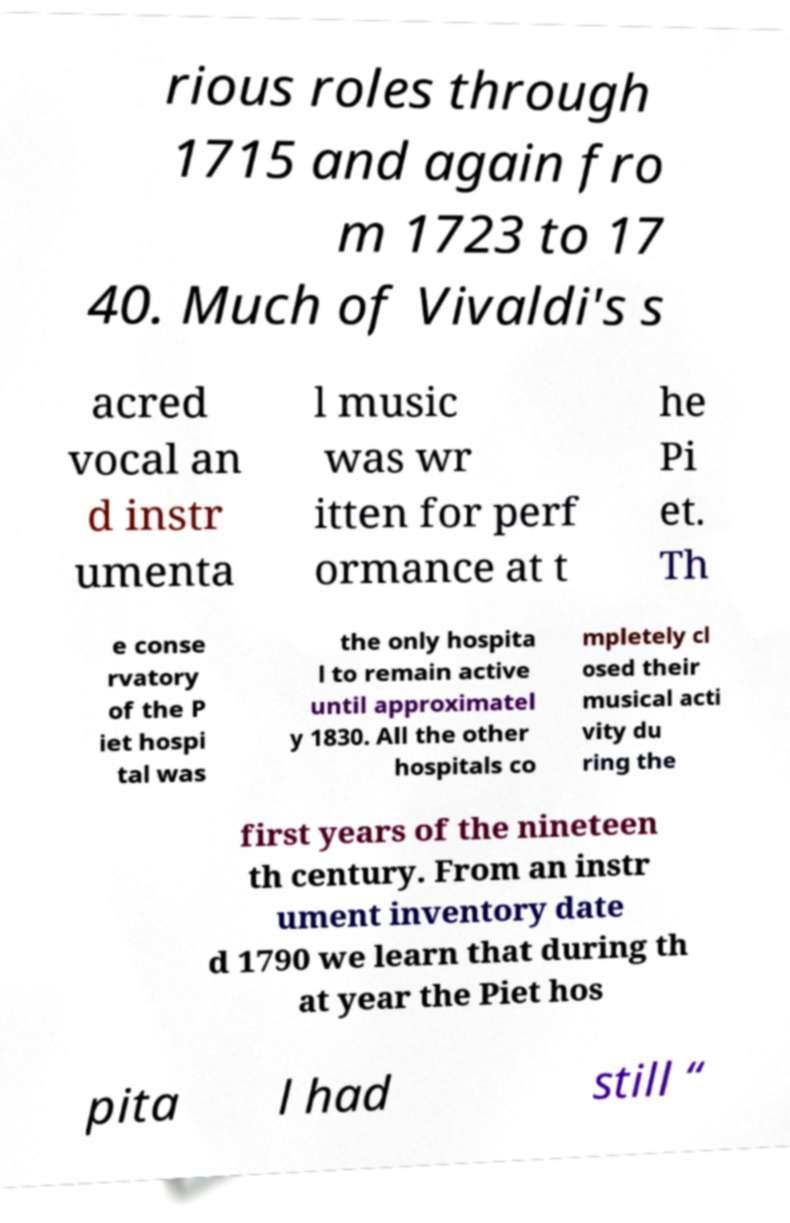Can you read and provide the text displayed in the image?This photo seems to have some interesting text. Can you extract and type it out for me? rious roles through 1715 and again fro m 1723 to 17 40. Much of Vivaldi's s acred vocal an d instr umenta l music was wr itten for perf ormance at t he Pi et. Th e conse rvatory of the P iet hospi tal was the only hospita l to remain active until approximatel y 1830. All the other hospitals co mpletely cl osed their musical acti vity du ring the first years of the nineteen th century. From an instr ument inventory date d 1790 we learn that during th at year the Piet hos pita l had still “ 